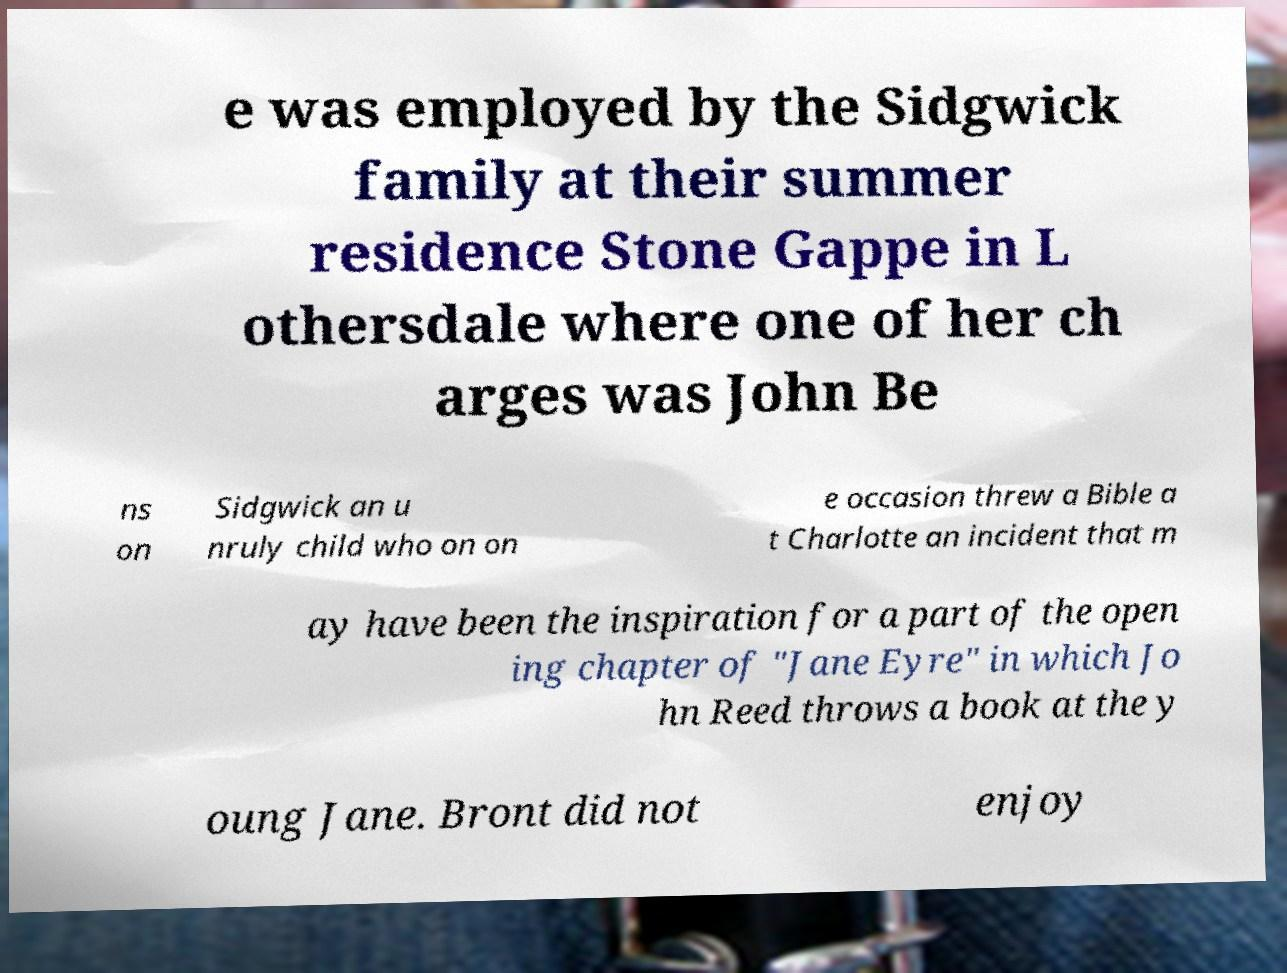There's text embedded in this image that I need extracted. Can you transcribe it verbatim? e was employed by the Sidgwick family at their summer residence Stone Gappe in L othersdale where one of her ch arges was John Be ns on Sidgwick an u nruly child who on on e occasion threw a Bible a t Charlotte an incident that m ay have been the inspiration for a part of the open ing chapter of "Jane Eyre" in which Jo hn Reed throws a book at the y oung Jane. Bront did not enjoy 